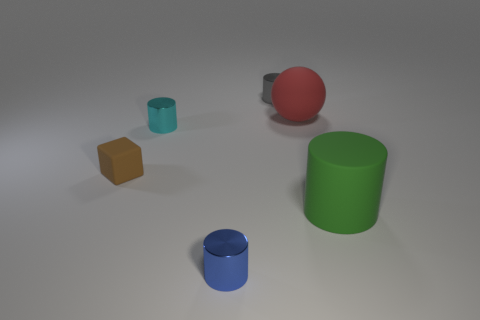Subtract all large cylinders. How many cylinders are left? 3 Subtract all cyan cylinders. How many cylinders are left? 3 Subtract all blocks. How many objects are left? 5 Add 3 green cylinders. How many objects exist? 9 Subtract 0 green cubes. How many objects are left? 6 Subtract 2 cylinders. How many cylinders are left? 2 Subtract all purple cylinders. Subtract all green spheres. How many cylinders are left? 4 Subtract all yellow cubes. How many gray cylinders are left? 1 Subtract all cyan things. Subtract all small brown rubber blocks. How many objects are left? 4 Add 6 small cyan cylinders. How many small cyan cylinders are left? 7 